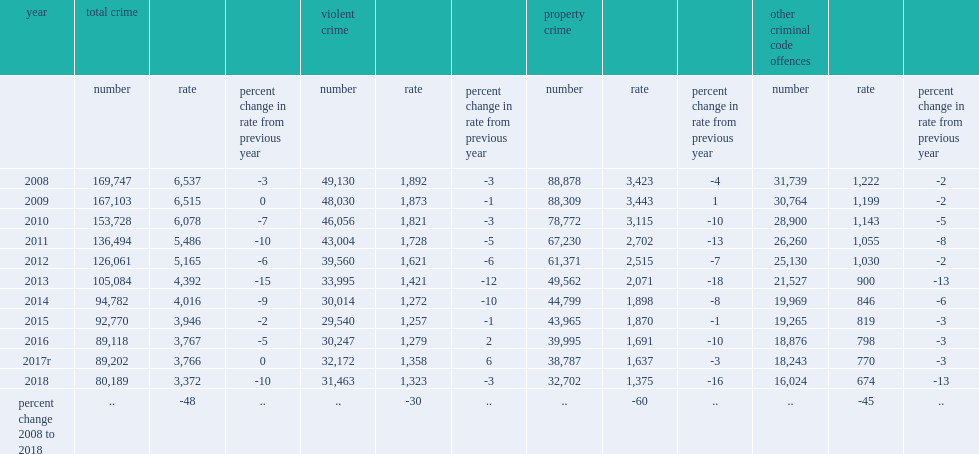Can you give me this table as a dict? {'header': ['year', 'total crime', '', '', 'violent crime', '', '', 'property crime', '', '', 'other criminal code offences', '', ''], 'rows': [['', 'number', 'rate', 'percent change in rate from previous year', 'number', 'rate', 'percent change in rate from previous year', 'number', 'rate', 'percent change in rate from previous year', 'number', 'rate', 'percent change in rate from previous year'], ['2008', '169,747', '6,537', '-3', '49,130', '1,892', '-3', '88,878', '3,423', '-4', '31,739', '1,222', '-2'], ['2009', '167,103', '6,515', '0', '48,030', '1,873', '-1', '88,309', '3,443', '1', '30,764', '1,199', '-2'], ['2010', '153,728', '6,078', '-7', '46,056', '1,821', '-3', '78,772', '3,115', '-10', '28,900', '1,143', '-5'], ['2011', '136,494', '5,486', '-10', '43,004', '1,728', '-5', '67,230', '2,702', '-13', '26,260', '1,055', '-8'], ['2012', '126,061', '5,165', '-6', '39,560', '1,621', '-6', '61,371', '2,515', '-7', '25,130', '1,030', '-2'], ['2013', '105,084', '4,392', '-15', '33,995', '1,421', '-12', '49,562', '2,071', '-18', '21,527', '900', '-13'], ['2014', '94,782', '4,016', '-9', '30,014', '1,272', '-10', '44,799', '1,898', '-8', '19,969', '846', '-6'], ['2015', '92,770', '3,946', '-2', '29,540', '1,257', '-1', '43,965', '1,870', '-1', '19,265', '819', '-3'], ['2016', '89,118', '3,767', '-5', '30,247', '1,279', '2', '39,995', '1,691', '-10', '18,876', '798', '-3'], ['2017r', '89,202', '3,766', '0', '32,172', '1,358', '6', '38,787', '1,637', '-3', '18,243', '770', '-3'], ['2018', '80,189', '3,372', '-10', '31,463', '1,323', '-3', '32,702', '1,375', '-16', '16,024', '674', '-13'], ['percent change 2008 to 2018', '..', '-48', '..', '..', '-30', '..', '..', '-60', '..', '..', '-45', '..']]} Which year made the largest decrease in the youth crime rate since 2013? 2018.0. 